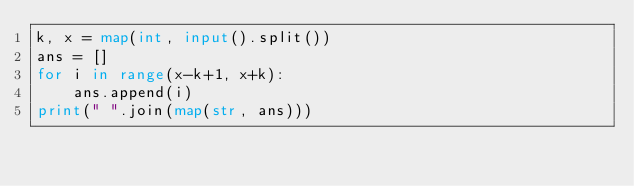Convert code to text. <code><loc_0><loc_0><loc_500><loc_500><_Python_>k, x = map(int, input().split())
ans = []
for i in range(x-k+1, x+k):
    ans.append(i)
print(" ".join(map(str, ans)))
</code> 